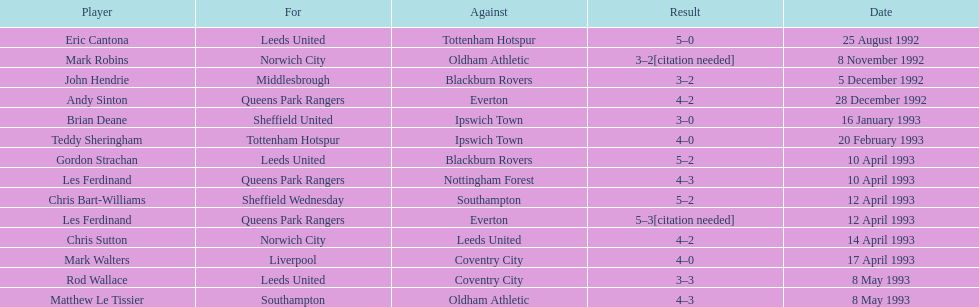Identify the one and only french player. Eric Cantona. 